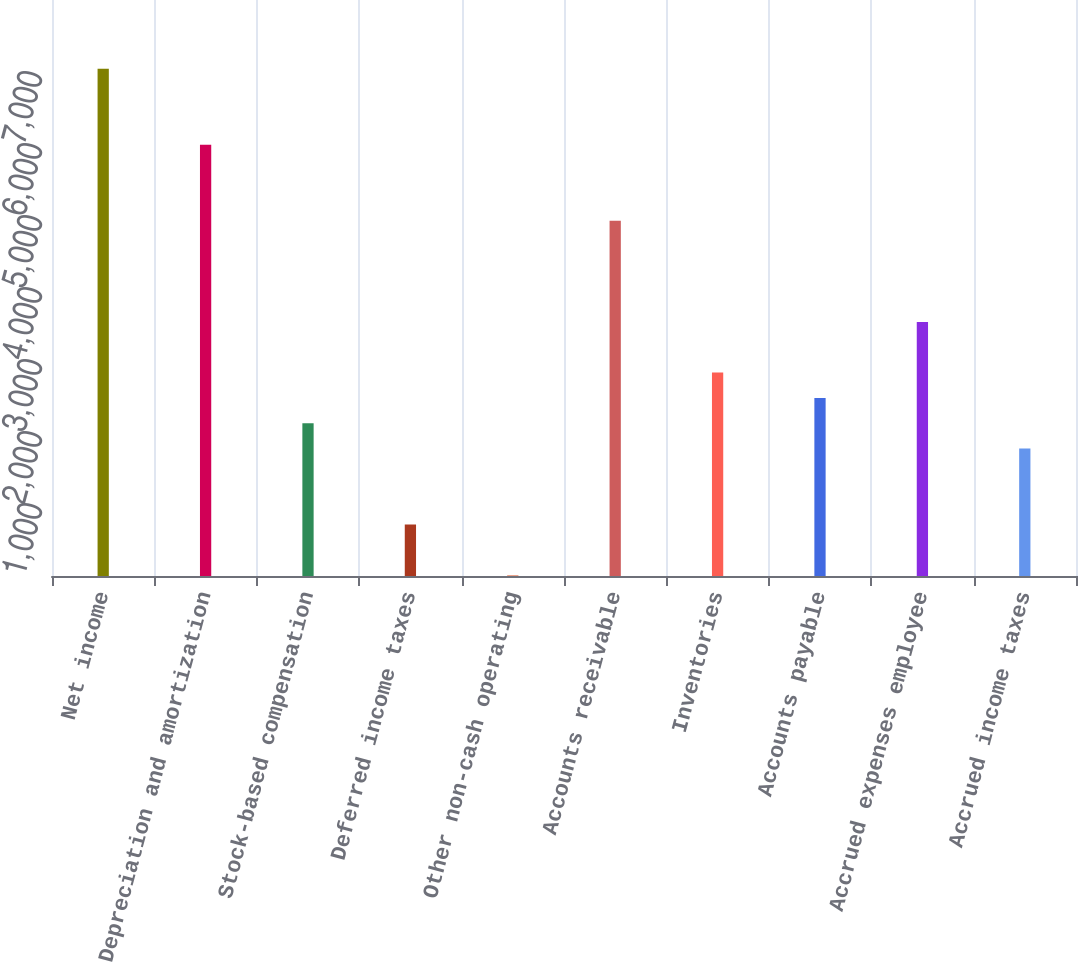Convert chart to OTSL. <chart><loc_0><loc_0><loc_500><loc_500><bar_chart><fcel>Net income<fcel>Depreciation and amortization<fcel>Stock-based compensation<fcel>Deferred income taxes<fcel>Other non-cash operating<fcel>Accounts receivable<fcel>Inventories<fcel>Accounts payable<fcel>Accrued expenses employee<fcel>Accrued income taxes<nl><fcel>7044<fcel>5989.2<fcel>2121.6<fcel>715.2<fcel>12<fcel>4934.4<fcel>2824.8<fcel>2473.2<fcel>3528<fcel>1770<nl></chart> 